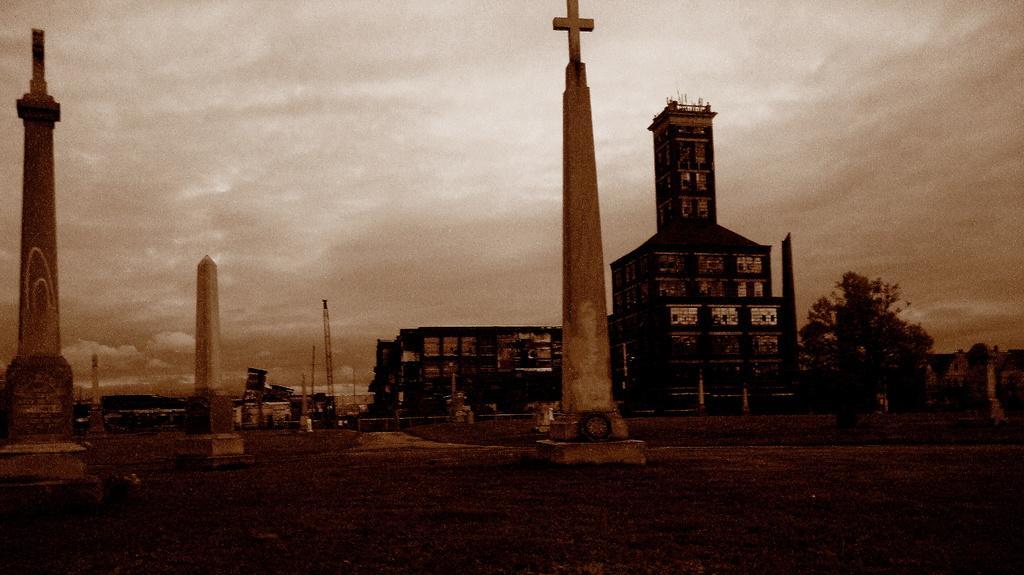Can you describe this image briefly? In this image there are buildings and towers. At the bottom there is a road and we can see trees, poles and sky. 